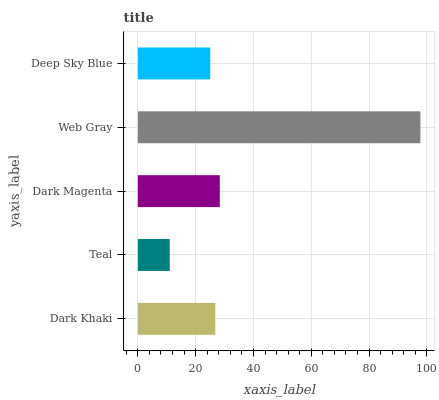Is Teal the minimum?
Answer yes or no. Yes. Is Web Gray the maximum?
Answer yes or no. Yes. Is Dark Magenta the minimum?
Answer yes or no. No. Is Dark Magenta the maximum?
Answer yes or no. No. Is Dark Magenta greater than Teal?
Answer yes or no. Yes. Is Teal less than Dark Magenta?
Answer yes or no. Yes. Is Teal greater than Dark Magenta?
Answer yes or no. No. Is Dark Magenta less than Teal?
Answer yes or no. No. Is Dark Khaki the high median?
Answer yes or no. Yes. Is Dark Khaki the low median?
Answer yes or no. Yes. Is Deep Sky Blue the high median?
Answer yes or no. No. Is Dark Magenta the low median?
Answer yes or no. No. 